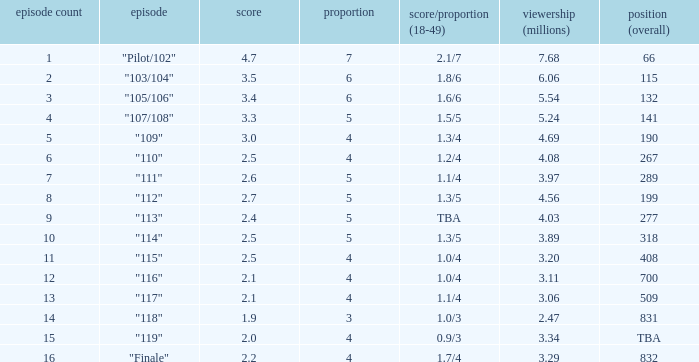Could you parse the entire table? {'header': ['episode count', 'episode', 'score', 'proportion', 'score/proportion (18-49)', 'viewership (millions)', 'position (overall)'], 'rows': [['1', '"Pilot/102"', '4.7', '7', '2.1/7', '7.68', '66'], ['2', '"103/104"', '3.5', '6', '1.8/6', '6.06', '115'], ['3', '"105/106"', '3.4', '6', '1.6/6', '5.54', '132'], ['4', '"107/108"', '3.3', '5', '1.5/5', '5.24', '141'], ['5', '"109"', '3.0', '4', '1.3/4', '4.69', '190'], ['6', '"110"', '2.5', '4', '1.2/4', '4.08', '267'], ['7', '"111"', '2.6', '5', '1.1/4', '3.97', '289'], ['8', '"112"', '2.7', '5', '1.3/5', '4.56', '199'], ['9', '"113"', '2.4', '5', 'TBA', '4.03', '277'], ['10', '"114"', '2.5', '5', '1.3/5', '3.89', '318'], ['11', '"115"', '2.5', '4', '1.0/4', '3.20', '408'], ['12', '"116"', '2.1', '4', '1.0/4', '3.11', '700'], ['13', '"117"', '2.1', '4', '1.1/4', '3.06', '509'], ['14', '"118"', '1.9', '3', '1.0/3', '2.47', '831'], ['15', '"119"', '2.0', '4', '0.9/3', '3.34', 'TBA'], ['16', '"Finale"', '2.2', '4', '1.7/4', '3.29', '832']]} WHAT IS THE NUMBER OF VIEWERS WITH EPISODE LARGER THAN 10, RATING SMALLER THAN 2? 2.47. 